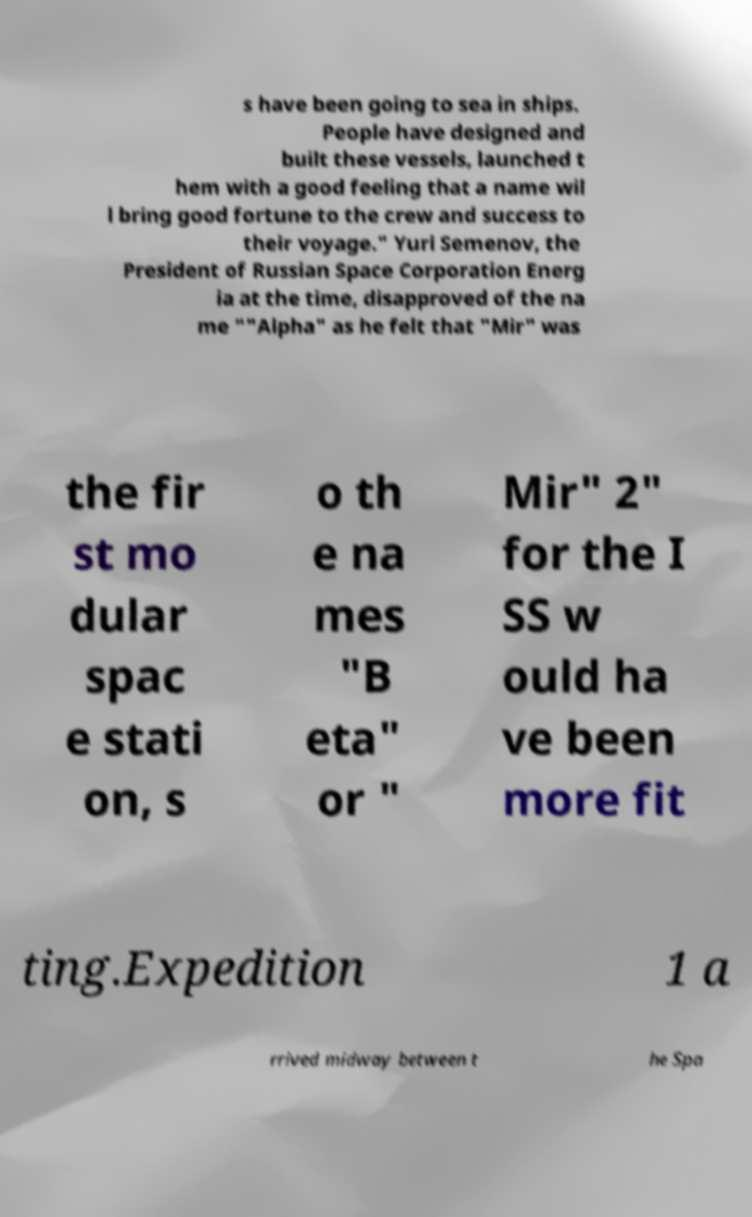What messages or text are displayed in this image? I need them in a readable, typed format. s have been going to sea in ships. People have designed and built these vessels, launched t hem with a good feeling that a name wil l bring good fortune to the crew and success to their voyage." Yuri Semenov, the President of Russian Space Corporation Energ ia at the time, disapproved of the na me ""Alpha" as he felt that "Mir" was the fir st mo dular spac e stati on, s o th e na mes "B eta" or " Mir" 2" for the I SS w ould ha ve been more fit ting.Expedition 1 a rrived midway between t he Spa 